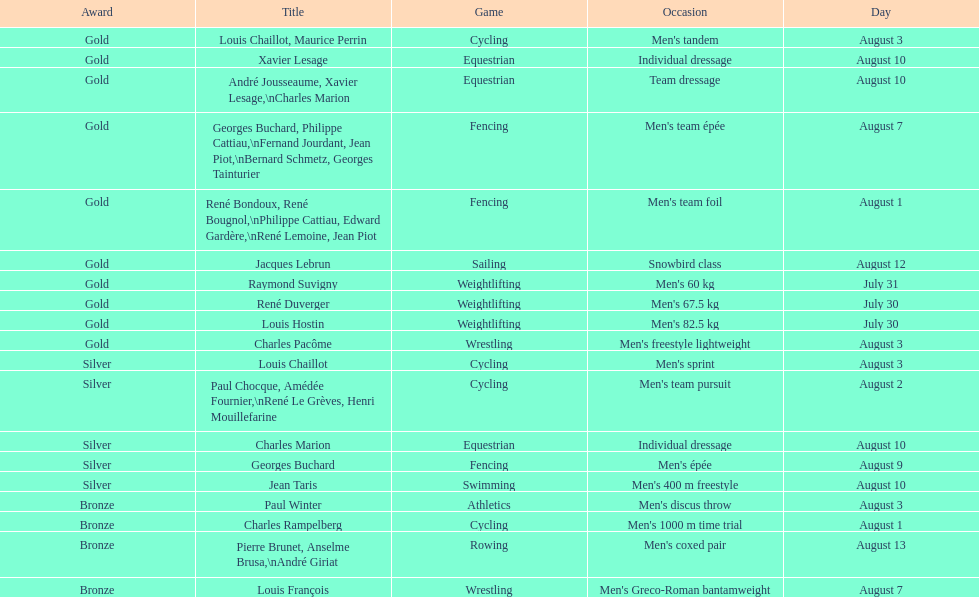In which sport did louis chalilot and paul chocque both win the same medal? Cycling. 